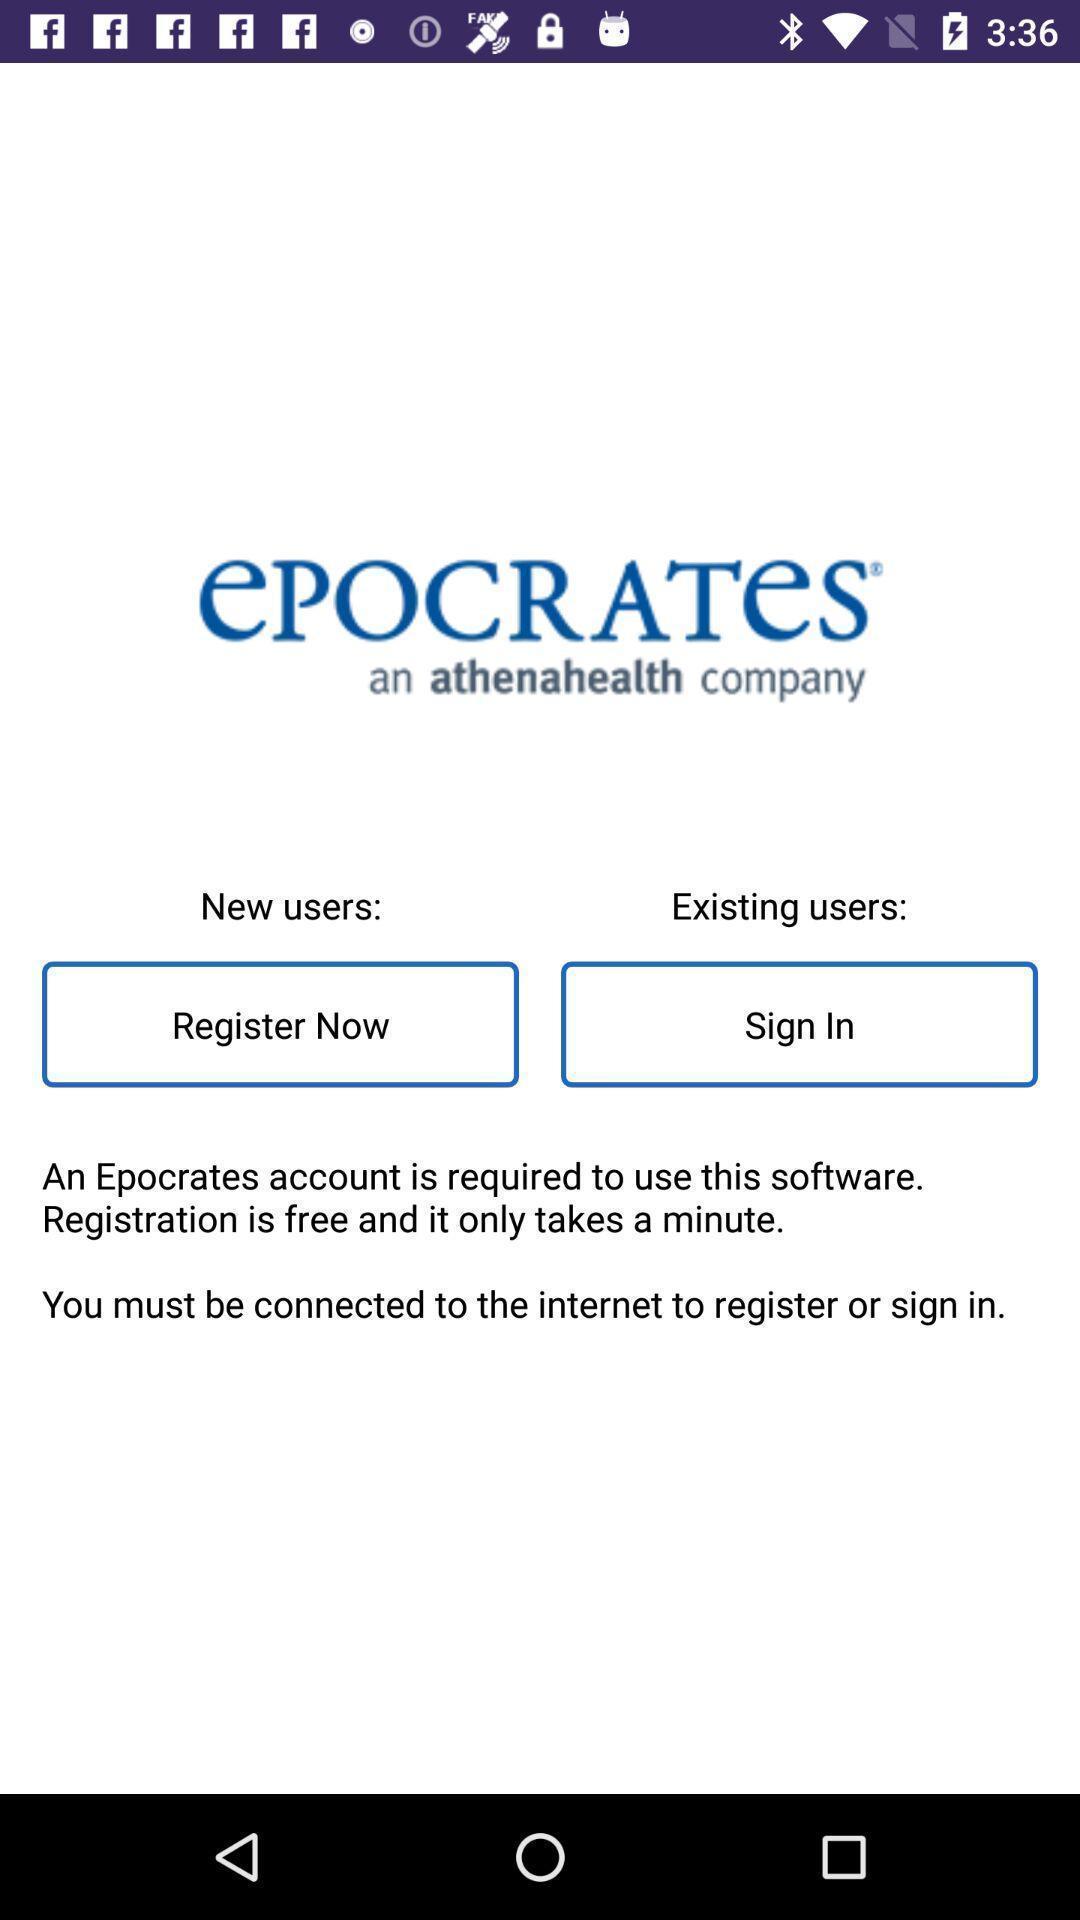Explain what's happening in this screen capture. Welcome page showing the options in leaning app. 